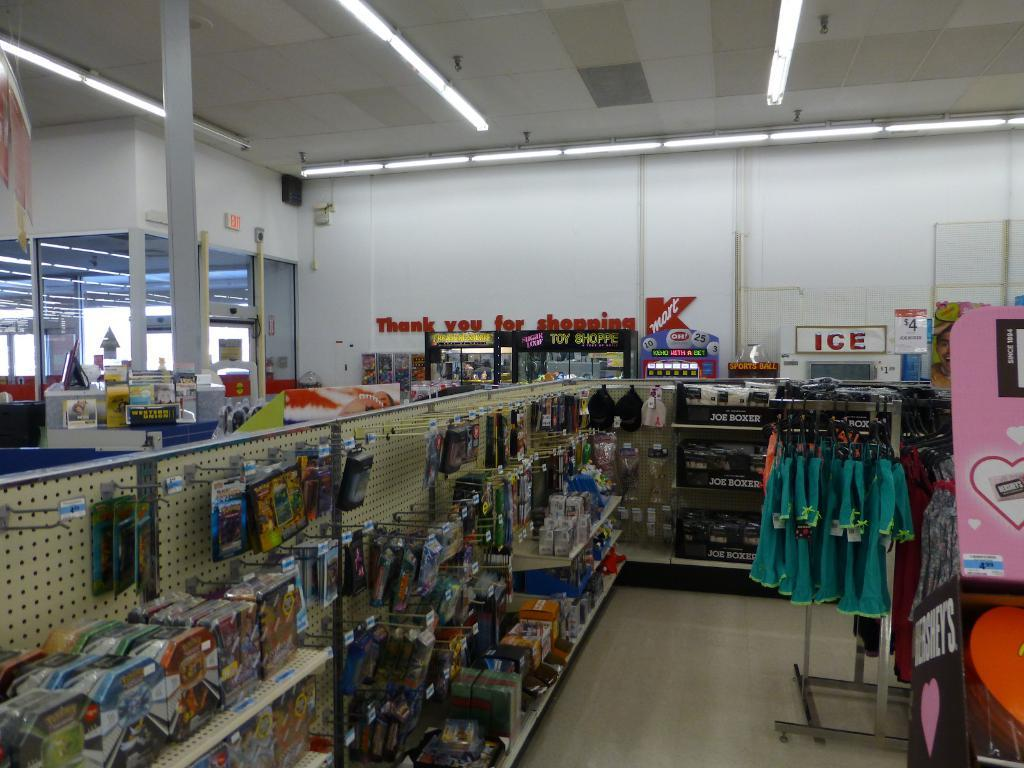<image>
Render a clear and concise summary of the photo. Inside of a Kmart store showing an toy asile 